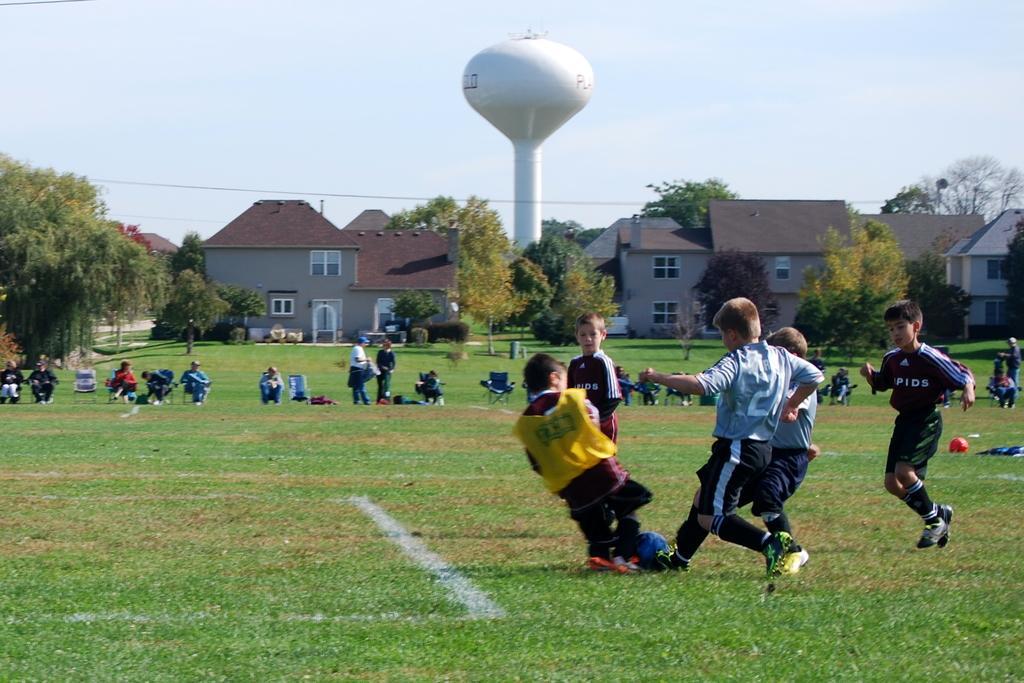How would you summarize this image in a sentence or two? this picture shows few boys playing football and we see couple of houses and trees around 